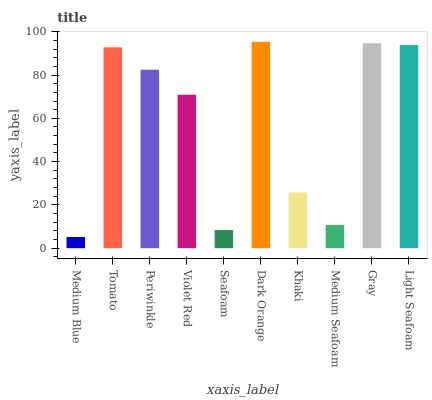Is Medium Blue the minimum?
Answer yes or no. Yes. Is Dark Orange the maximum?
Answer yes or no. Yes. Is Tomato the minimum?
Answer yes or no. No. Is Tomato the maximum?
Answer yes or no. No. Is Tomato greater than Medium Blue?
Answer yes or no. Yes. Is Medium Blue less than Tomato?
Answer yes or no. Yes. Is Medium Blue greater than Tomato?
Answer yes or no. No. Is Tomato less than Medium Blue?
Answer yes or no. No. Is Periwinkle the high median?
Answer yes or no. Yes. Is Violet Red the low median?
Answer yes or no. Yes. Is Medium Blue the high median?
Answer yes or no. No. Is Medium Blue the low median?
Answer yes or no. No. 